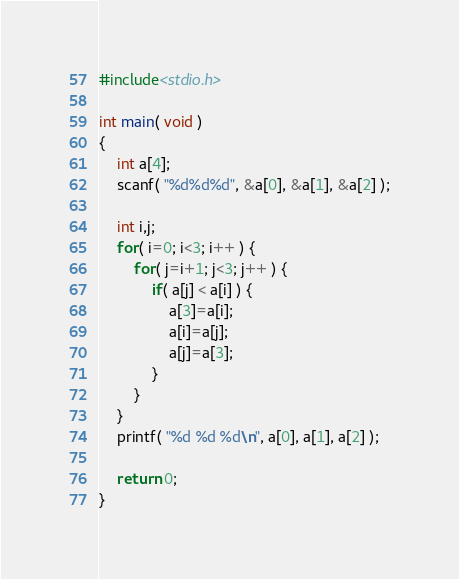Convert code to text. <code><loc_0><loc_0><loc_500><loc_500><_C_>#include<stdio.h>

int main( void ) 
{
	int a[4];
	scanf( "%d%d%d", &a[0], &a[1], &a[2] );

	int i,j;
	for( i=0; i<3; i++ ) {
		for( j=i+1; j<3; j++ ) {
			if( a[j] < a[i] ) {
				a[3]=a[i];
				a[i]=a[j];
				a[j]=a[3];
			}
		}
	}
	printf( "%d %d %d\n", a[0], a[1], a[2] );
	
	return 0;
}</code> 